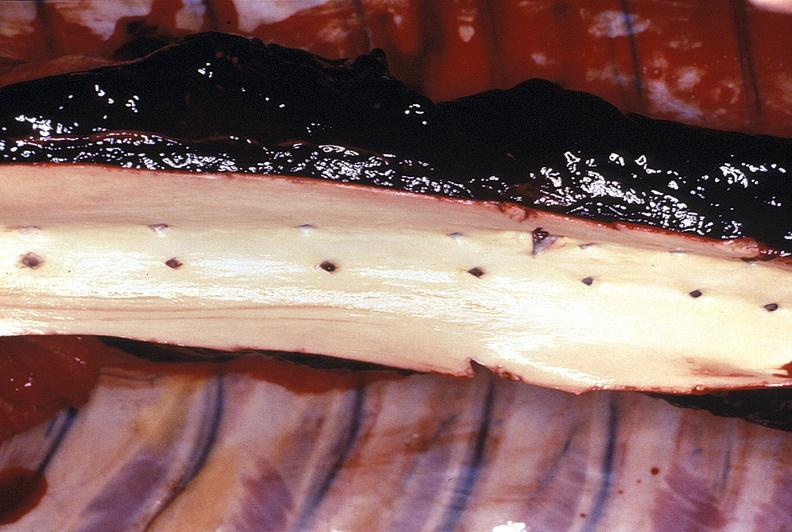what is present?
Answer the question using a single word or phrase. Cardiovascular 